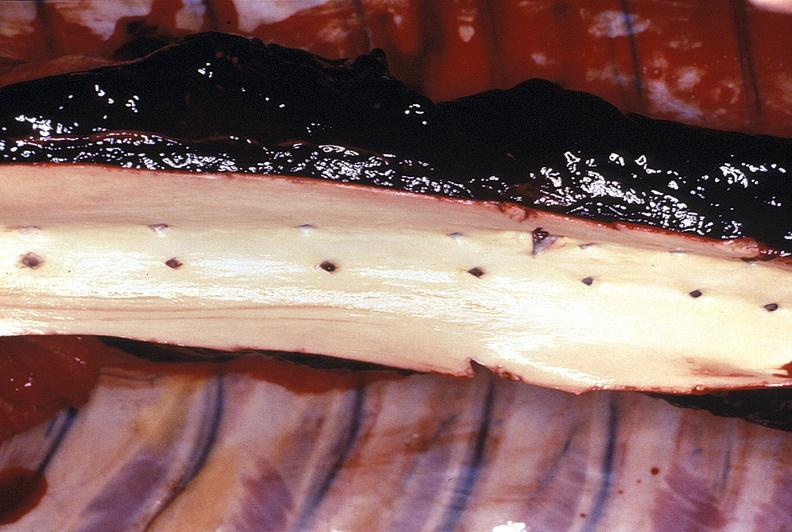what is present?
Answer the question using a single word or phrase. Cardiovascular 